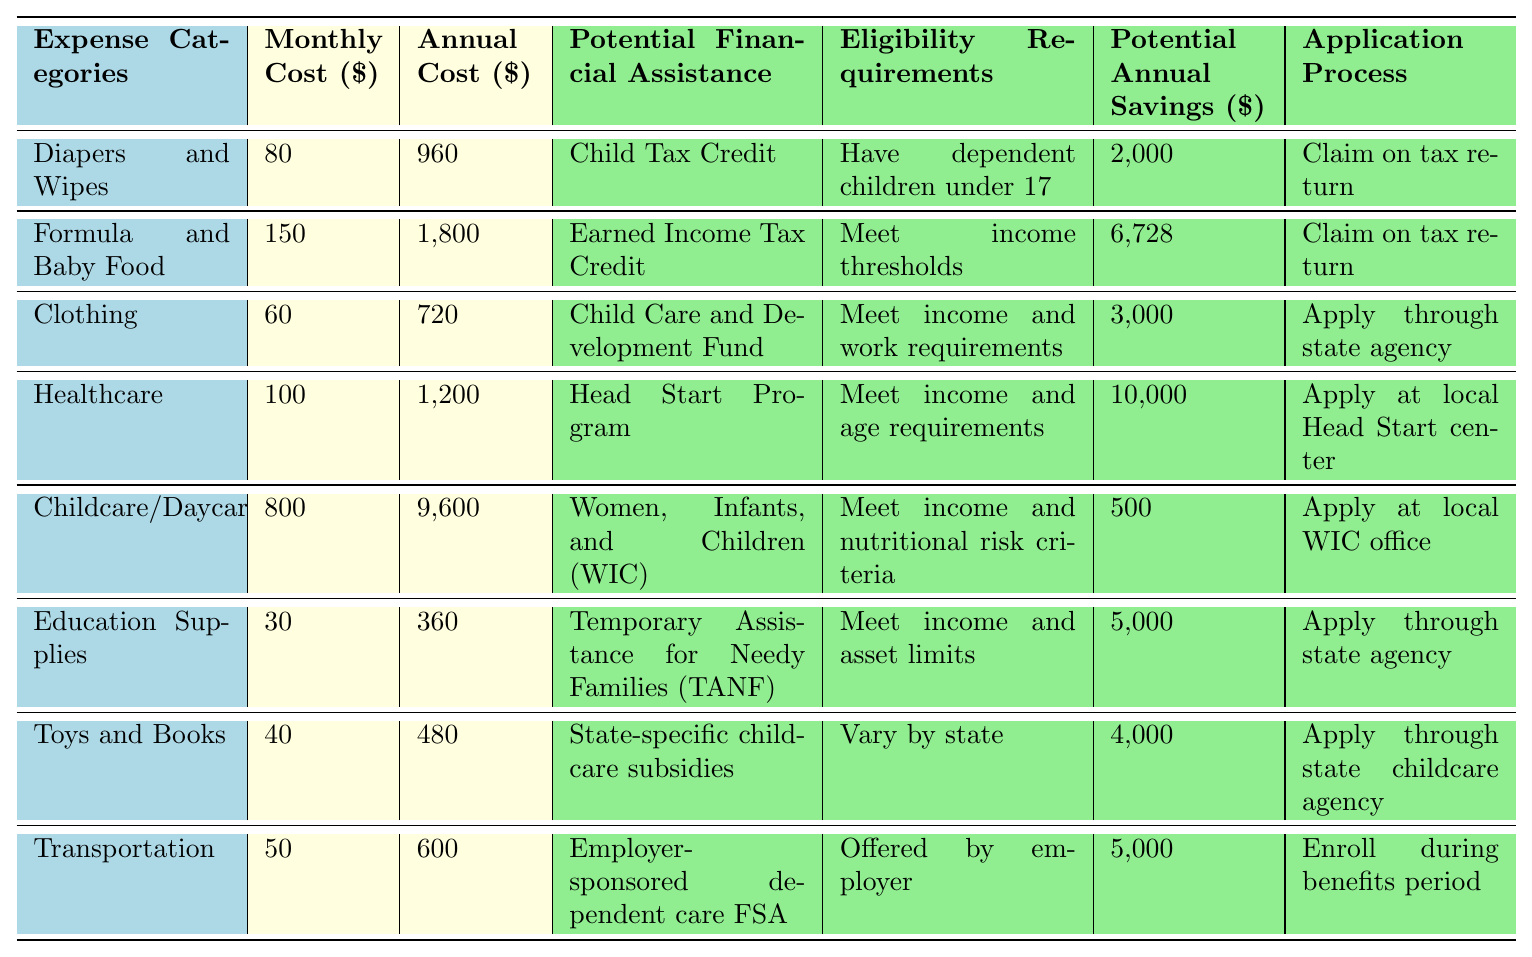What is the monthly cost estimate for Childcare/Daycare? The table lists the monthly cost estimates for each expense category. For Childcare/Daycare, the value is directly provided as $800.
Answer: 800 What is the potential annual savings for the Child Tax Credit? The potential annual savings for the Child Tax Credit is included in the table, where it states $2,000 specifically for this financial assistance option.
Answer: 2000 Which expense category has the highest annual cost estimate? By reviewing the annual cost estimates, Childcare/Daycare shows the highest value at $9,600 compared to the others.
Answer: Childcare/Daycare Are all the potential financial assistance options available for families regardless of their income? The table indicates specific eligibility requirements for each financial assistance option, including the necessity to meet income thresholds, thus they are not all available regardless of income.
Answer: No What is the total potential annual savings from Clothing and Transportation? Listing out the potential annual savings: Clothing is $3,000 and Transportation is $5,000. Adding these two gives $3,000 + $5,000 = $8,000.
Answer: 8000 Does the Head Start Program require a specific age criterion? The eligibility requirement for the Head Start Program states it requires meeting income and age requirements, implying an age criterion is indeed necessary.
Answer: Yes How much can a family save in total if they utilize all types of potential financial assistance listed? Summing all potential annual savings: $2,000 (Child Tax Credit) + $6,728 (Earned Income Tax Credit) + $3,000 (Child Care and Development Fund) + $10,000 (Head Start Program) + $500 (WIC) + $5,000 (TANF) + $4,000 (childcare subsidies) + $5,000 (employer FSA) gives $36,228.
Answer: 36228 Is there any financial assistance that requires applying at a local office? The table shows that both the Head Start Program and WIC require applications at local offices as noted in their application processes.
Answer: Yes What is the difference between the monthly costs for Diapers and Wipes and Education Supplies? The monthly cost for Diapers and Wipes is $80 while Education Supplies is $30. Calculating the difference: $80 - $30 equals $50.
Answer: 50 Which categories offer potential financial assistance that is dependent on state-specific requirements? The entry for State-specific childcare subsidies notes that eligibility requirements vary by state, identifying it as conditionally dependent on state regulations.
Answer: State-specific childcare subsidies 